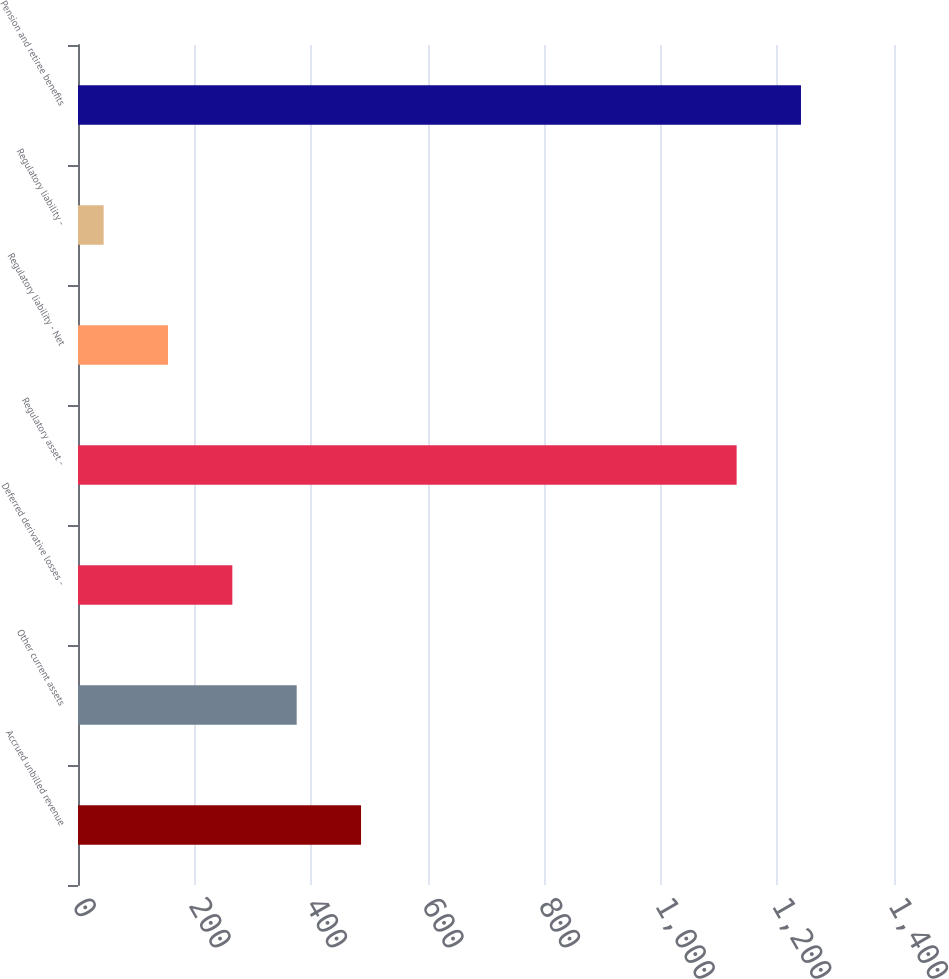<chart> <loc_0><loc_0><loc_500><loc_500><bar_chart><fcel>Accrued unbilled revenue<fcel>Other current assets<fcel>Deferred derivative losses -<fcel>Regulatory asset -<fcel>Regulatory liability - Net<fcel>Regulatory liability -<fcel>Pension and retiree benefits<nl><fcel>485.6<fcel>375.2<fcel>264.8<fcel>1130<fcel>154.4<fcel>44<fcel>1240.4<nl></chart> 